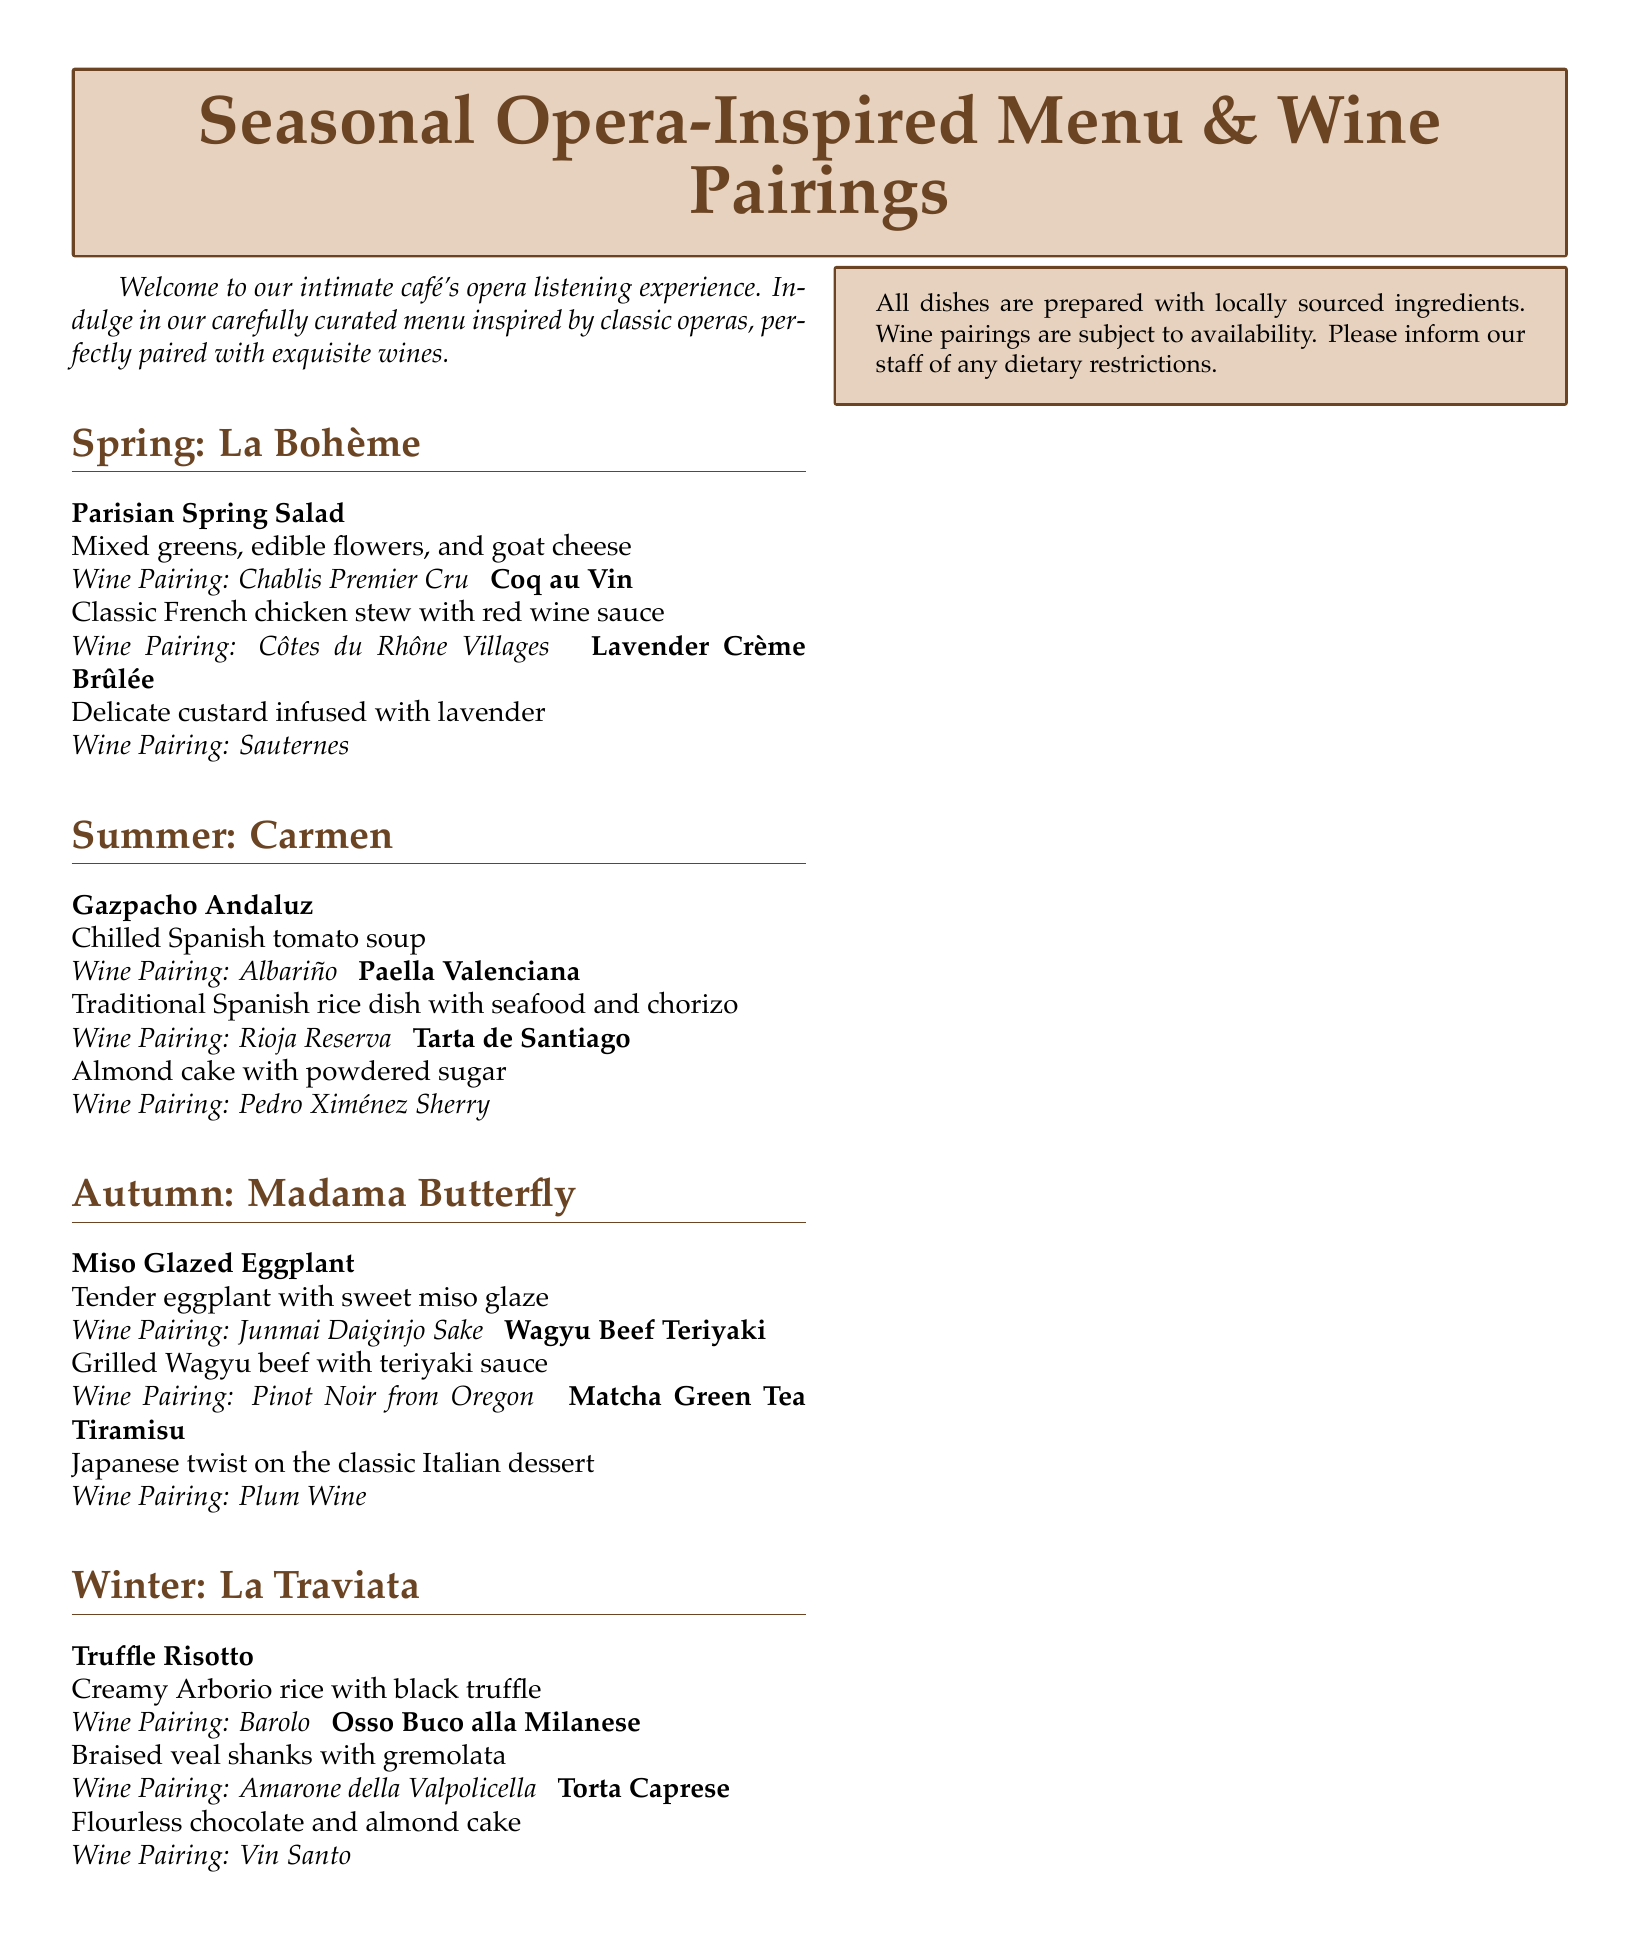what is the title of the menu? The title of the menu is presented prominently at the top of the document.
Answer: Seasonal Opera-Inspired Menu & Wine Pairings how many seasons are included in the menu? Each section in the document represents a different season, totaling four sections.
Answer: 4 which opera is associated with the Spring menu? The Spring menu is inspired by a specific opera, stated clearly in the section header.
Answer: La Bohème what wine is paired with Miso Glazed Eggplant? The dish pairing indicates the chosen wine for this specific menu item under Autumn.
Answer: Junmai Daiginjo Sake which dessert is offered in Winter? The Winter section lists a specific dessert option that is included.
Answer: Torta Caprese what is the main ingredient in the Coq au Vin dish? The description of this dish indicates its main ingredient, which is essential to its identity.
Answer: Chicken which season features Tarta de Santiago? The dessert is listed under the section for a specific season that aligns with its theme.
Answer: Summer what type of dish is Wagyu Beef Teriyaki? This dish description provides information about its cooking style and ingredient.
Answer: Grilled what color is the box used for the menu title? The color used for the title box is explicitly mentioned as part of the design.
Answer: Lightcafe 